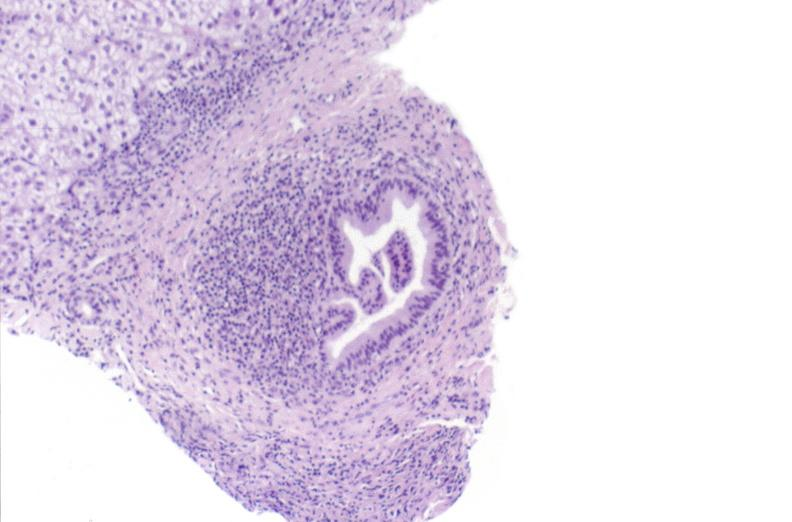what is present?
Answer the question using a single word or phrase. Liver 